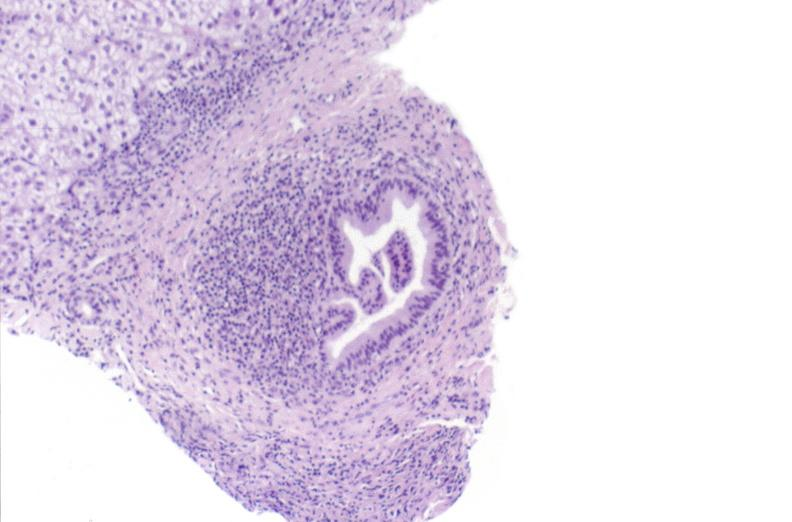what is present?
Answer the question using a single word or phrase. Liver 